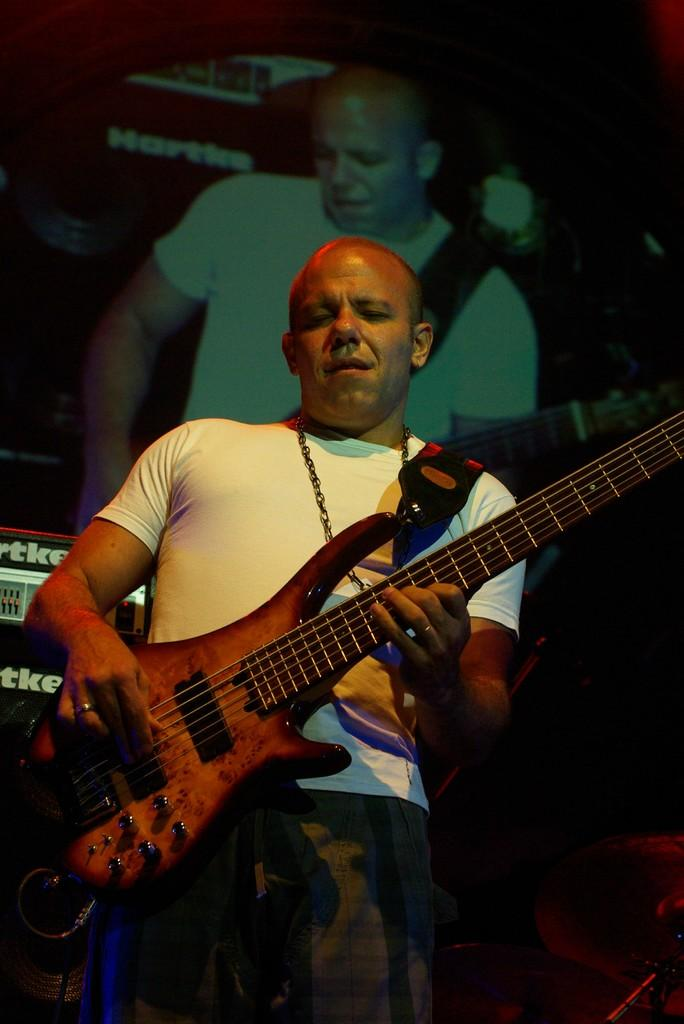What is the man in the image doing? The man is playing the guitar in the image. What object is the man holding while playing the guitar? The man is holding a guitar. What can be seen in the background of the image? There is a screen visible in the background of the image. Who is visible on the screen? The same person who is playing the guitar is visible on the screen. What type of creature is shown drinking liquid from a bowl on the screen? There is no creature or liquid present on the screen; it shows the same person who is playing the guitar. 